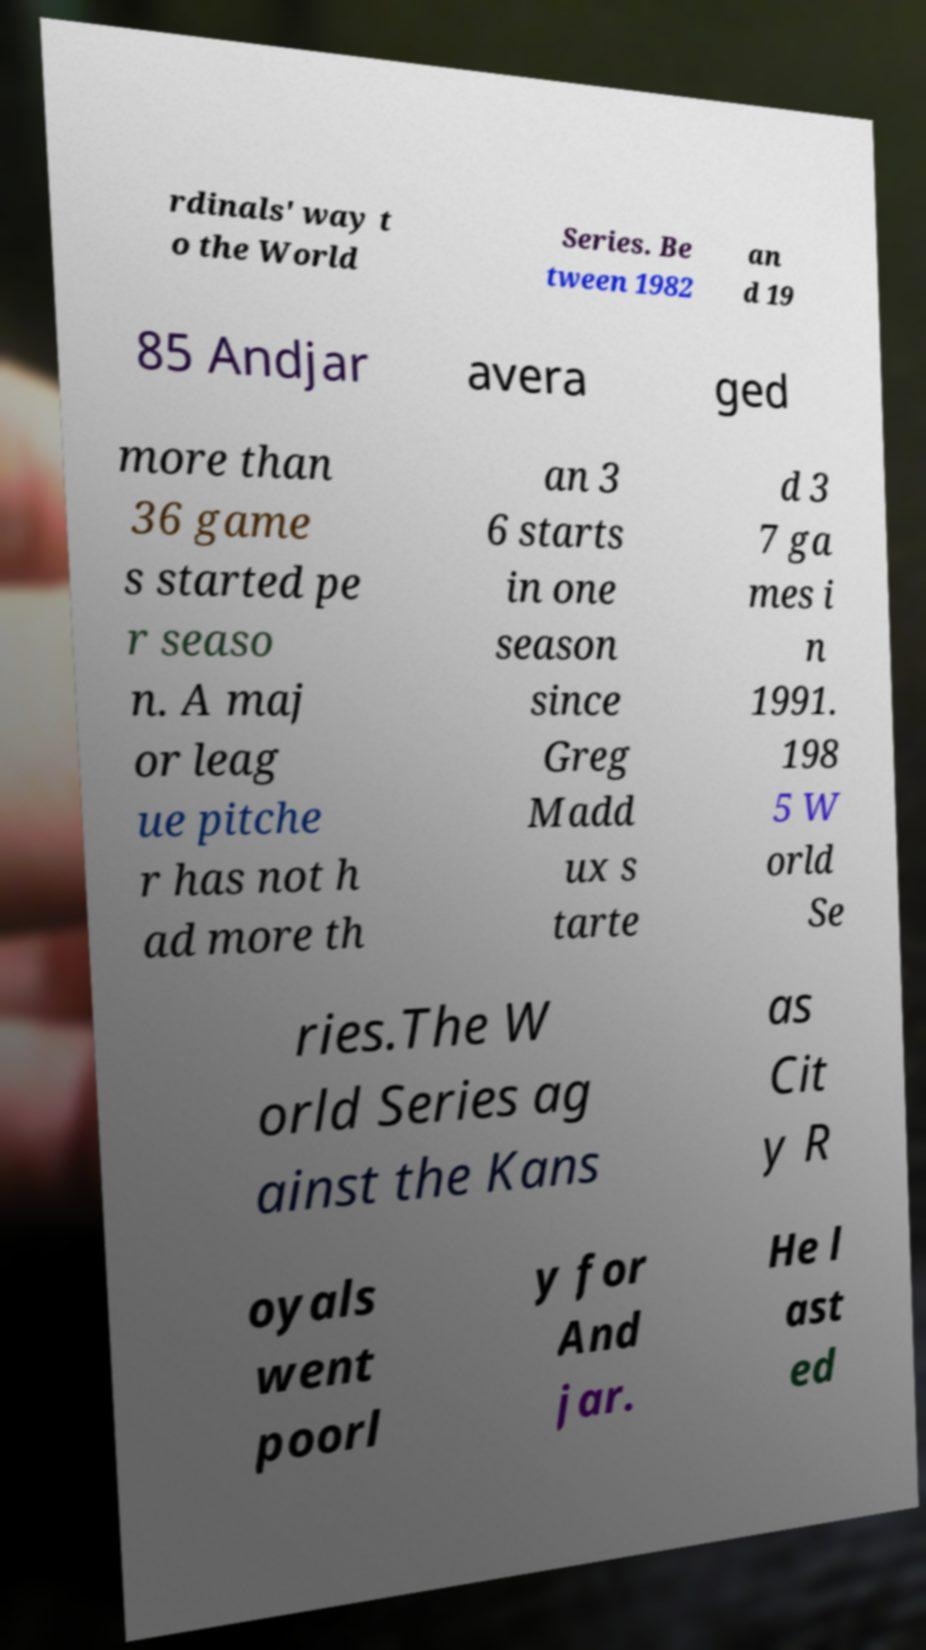Could you assist in decoding the text presented in this image and type it out clearly? rdinals' way t o the World Series. Be tween 1982 an d 19 85 Andjar avera ged more than 36 game s started pe r seaso n. A maj or leag ue pitche r has not h ad more th an 3 6 starts in one season since Greg Madd ux s tarte d 3 7 ga mes i n 1991. 198 5 W orld Se ries.The W orld Series ag ainst the Kans as Cit y R oyals went poorl y for And jar. He l ast ed 